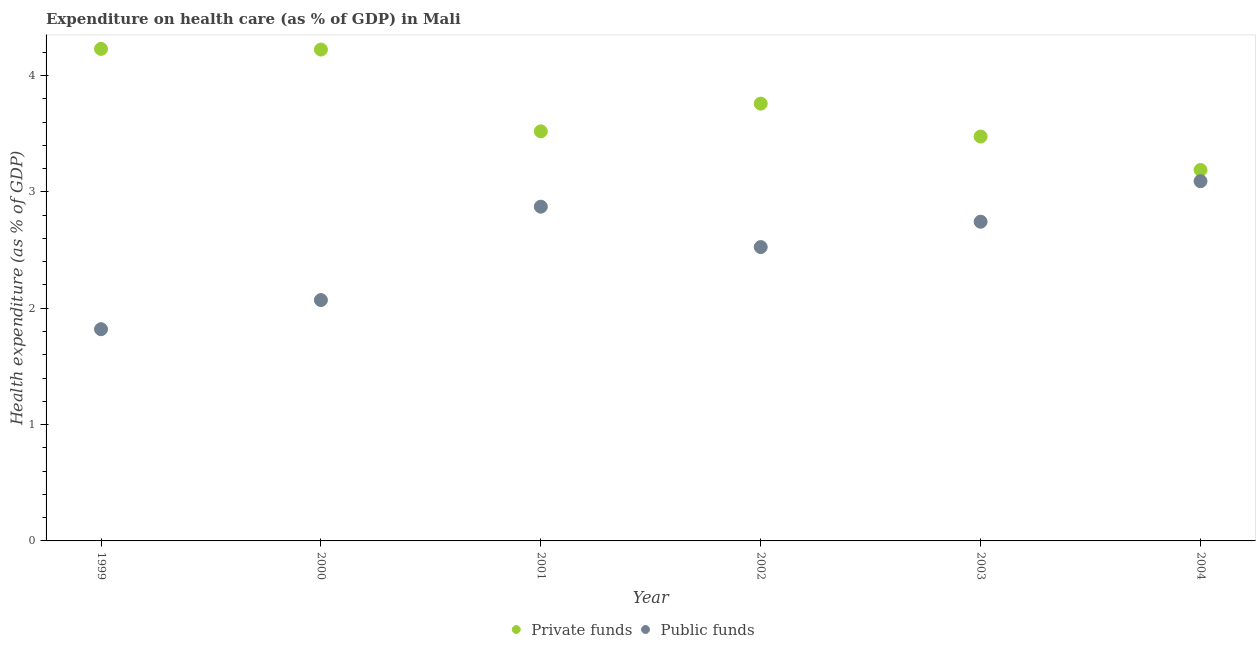How many different coloured dotlines are there?
Provide a short and direct response. 2. Is the number of dotlines equal to the number of legend labels?
Offer a very short reply. Yes. What is the amount of public funds spent in healthcare in 2000?
Provide a short and direct response. 2.07. Across all years, what is the maximum amount of private funds spent in healthcare?
Make the answer very short. 4.23. Across all years, what is the minimum amount of public funds spent in healthcare?
Offer a terse response. 1.82. In which year was the amount of private funds spent in healthcare maximum?
Ensure brevity in your answer.  1999. What is the total amount of public funds spent in healthcare in the graph?
Your response must be concise. 15.12. What is the difference between the amount of private funds spent in healthcare in 1999 and that in 2000?
Provide a short and direct response. 0.01. What is the difference between the amount of public funds spent in healthcare in 1999 and the amount of private funds spent in healthcare in 2002?
Your answer should be very brief. -1.94. What is the average amount of private funds spent in healthcare per year?
Make the answer very short. 3.73. In the year 2002, what is the difference between the amount of public funds spent in healthcare and amount of private funds spent in healthcare?
Provide a succinct answer. -1.23. In how many years, is the amount of public funds spent in healthcare greater than 4 %?
Your answer should be compact. 0. What is the ratio of the amount of private funds spent in healthcare in 1999 to that in 2004?
Offer a terse response. 1.33. Is the difference between the amount of public funds spent in healthcare in 2000 and 2001 greater than the difference between the amount of private funds spent in healthcare in 2000 and 2001?
Keep it short and to the point. No. What is the difference between the highest and the second highest amount of public funds spent in healthcare?
Offer a terse response. 0.22. What is the difference between the highest and the lowest amount of public funds spent in healthcare?
Give a very brief answer. 1.27. Does the amount of private funds spent in healthcare monotonically increase over the years?
Provide a succinct answer. No. Is the amount of public funds spent in healthcare strictly greater than the amount of private funds spent in healthcare over the years?
Offer a very short reply. No. How many dotlines are there?
Your answer should be compact. 2. How many years are there in the graph?
Offer a terse response. 6. Does the graph contain any zero values?
Provide a short and direct response. No. Where does the legend appear in the graph?
Keep it short and to the point. Bottom center. How are the legend labels stacked?
Ensure brevity in your answer.  Horizontal. What is the title of the graph?
Ensure brevity in your answer.  Expenditure on health care (as % of GDP) in Mali. Does "Fraud firms" appear as one of the legend labels in the graph?
Keep it short and to the point. No. What is the label or title of the X-axis?
Offer a very short reply. Year. What is the label or title of the Y-axis?
Ensure brevity in your answer.  Health expenditure (as % of GDP). What is the Health expenditure (as % of GDP) in Private funds in 1999?
Your answer should be very brief. 4.23. What is the Health expenditure (as % of GDP) of Public funds in 1999?
Offer a terse response. 1.82. What is the Health expenditure (as % of GDP) of Private funds in 2000?
Ensure brevity in your answer.  4.22. What is the Health expenditure (as % of GDP) of Public funds in 2000?
Keep it short and to the point. 2.07. What is the Health expenditure (as % of GDP) of Private funds in 2001?
Offer a very short reply. 3.52. What is the Health expenditure (as % of GDP) of Public funds in 2001?
Offer a very short reply. 2.87. What is the Health expenditure (as % of GDP) in Private funds in 2002?
Provide a short and direct response. 3.76. What is the Health expenditure (as % of GDP) of Public funds in 2002?
Offer a terse response. 2.53. What is the Health expenditure (as % of GDP) of Private funds in 2003?
Provide a succinct answer. 3.48. What is the Health expenditure (as % of GDP) of Public funds in 2003?
Provide a short and direct response. 2.74. What is the Health expenditure (as % of GDP) of Private funds in 2004?
Your answer should be compact. 3.19. What is the Health expenditure (as % of GDP) in Public funds in 2004?
Keep it short and to the point. 3.09. Across all years, what is the maximum Health expenditure (as % of GDP) of Private funds?
Give a very brief answer. 4.23. Across all years, what is the maximum Health expenditure (as % of GDP) of Public funds?
Ensure brevity in your answer.  3.09. Across all years, what is the minimum Health expenditure (as % of GDP) in Private funds?
Your answer should be compact. 3.19. Across all years, what is the minimum Health expenditure (as % of GDP) of Public funds?
Your answer should be very brief. 1.82. What is the total Health expenditure (as % of GDP) in Private funds in the graph?
Ensure brevity in your answer.  22.39. What is the total Health expenditure (as % of GDP) in Public funds in the graph?
Keep it short and to the point. 15.12. What is the difference between the Health expenditure (as % of GDP) in Private funds in 1999 and that in 2000?
Provide a short and direct response. 0.01. What is the difference between the Health expenditure (as % of GDP) in Public funds in 1999 and that in 2000?
Keep it short and to the point. -0.25. What is the difference between the Health expenditure (as % of GDP) of Private funds in 1999 and that in 2001?
Ensure brevity in your answer.  0.71. What is the difference between the Health expenditure (as % of GDP) in Public funds in 1999 and that in 2001?
Your response must be concise. -1.05. What is the difference between the Health expenditure (as % of GDP) in Private funds in 1999 and that in 2002?
Keep it short and to the point. 0.47. What is the difference between the Health expenditure (as % of GDP) in Public funds in 1999 and that in 2002?
Provide a succinct answer. -0.71. What is the difference between the Health expenditure (as % of GDP) in Private funds in 1999 and that in 2003?
Offer a terse response. 0.75. What is the difference between the Health expenditure (as % of GDP) of Public funds in 1999 and that in 2003?
Give a very brief answer. -0.92. What is the difference between the Health expenditure (as % of GDP) of Private funds in 1999 and that in 2004?
Your answer should be compact. 1.04. What is the difference between the Health expenditure (as % of GDP) of Public funds in 1999 and that in 2004?
Offer a very short reply. -1.27. What is the difference between the Health expenditure (as % of GDP) of Private funds in 2000 and that in 2001?
Keep it short and to the point. 0.7. What is the difference between the Health expenditure (as % of GDP) of Public funds in 2000 and that in 2001?
Your answer should be very brief. -0.8. What is the difference between the Health expenditure (as % of GDP) of Private funds in 2000 and that in 2002?
Provide a succinct answer. 0.46. What is the difference between the Health expenditure (as % of GDP) in Public funds in 2000 and that in 2002?
Make the answer very short. -0.46. What is the difference between the Health expenditure (as % of GDP) of Private funds in 2000 and that in 2003?
Give a very brief answer. 0.75. What is the difference between the Health expenditure (as % of GDP) in Public funds in 2000 and that in 2003?
Your answer should be very brief. -0.67. What is the difference between the Health expenditure (as % of GDP) of Private funds in 2000 and that in 2004?
Your answer should be compact. 1.04. What is the difference between the Health expenditure (as % of GDP) of Public funds in 2000 and that in 2004?
Your answer should be compact. -1.02. What is the difference between the Health expenditure (as % of GDP) in Private funds in 2001 and that in 2002?
Offer a terse response. -0.24. What is the difference between the Health expenditure (as % of GDP) of Public funds in 2001 and that in 2002?
Provide a succinct answer. 0.35. What is the difference between the Health expenditure (as % of GDP) in Private funds in 2001 and that in 2003?
Ensure brevity in your answer.  0.05. What is the difference between the Health expenditure (as % of GDP) in Public funds in 2001 and that in 2003?
Your answer should be compact. 0.13. What is the difference between the Health expenditure (as % of GDP) of Private funds in 2001 and that in 2004?
Offer a very short reply. 0.33. What is the difference between the Health expenditure (as % of GDP) in Public funds in 2001 and that in 2004?
Offer a terse response. -0.22. What is the difference between the Health expenditure (as % of GDP) of Private funds in 2002 and that in 2003?
Offer a terse response. 0.28. What is the difference between the Health expenditure (as % of GDP) of Public funds in 2002 and that in 2003?
Provide a succinct answer. -0.22. What is the difference between the Health expenditure (as % of GDP) in Private funds in 2002 and that in 2004?
Offer a very short reply. 0.57. What is the difference between the Health expenditure (as % of GDP) in Public funds in 2002 and that in 2004?
Ensure brevity in your answer.  -0.57. What is the difference between the Health expenditure (as % of GDP) of Private funds in 2003 and that in 2004?
Ensure brevity in your answer.  0.29. What is the difference between the Health expenditure (as % of GDP) of Public funds in 2003 and that in 2004?
Your answer should be compact. -0.35. What is the difference between the Health expenditure (as % of GDP) of Private funds in 1999 and the Health expenditure (as % of GDP) of Public funds in 2000?
Ensure brevity in your answer.  2.16. What is the difference between the Health expenditure (as % of GDP) of Private funds in 1999 and the Health expenditure (as % of GDP) of Public funds in 2001?
Your answer should be compact. 1.36. What is the difference between the Health expenditure (as % of GDP) in Private funds in 1999 and the Health expenditure (as % of GDP) in Public funds in 2002?
Offer a very short reply. 1.7. What is the difference between the Health expenditure (as % of GDP) in Private funds in 1999 and the Health expenditure (as % of GDP) in Public funds in 2003?
Keep it short and to the point. 1.49. What is the difference between the Health expenditure (as % of GDP) in Private funds in 1999 and the Health expenditure (as % of GDP) in Public funds in 2004?
Offer a very short reply. 1.14. What is the difference between the Health expenditure (as % of GDP) of Private funds in 2000 and the Health expenditure (as % of GDP) of Public funds in 2001?
Your answer should be very brief. 1.35. What is the difference between the Health expenditure (as % of GDP) of Private funds in 2000 and the Health expenditure (as % of GDP) of Public funds in 2002?
Give a very brief answer. 1.7. What is the difference between the Health expenditure (as % of GDP) of Private funds in 2000 and the Health expenditure (as % of GDP) of Public funds in 2003?
Provide a succinct answer. 1.48. What is the difference between the Health expenditure (as % of GDP) in Private funds in 2000 and the Health expenditure (as % of GDP) in Public funds in 2004?
Give a very brief answer. 1.13. What is the difference between the Health expenditure (as % of GDP) of Private funds in 2001 and the Health expenditure (as % of GDP) of Public funds in 2002?
Give a very brief answer. 0.99. What is the difference between the Health expenditure (as % of GDP) in Private funds in 2001 and the Health expenditure (as % of GDP) in Public funds in 2003?
Ensure brevity in your answer.  0.78. What is the difference between the Health expenditure (as % of GDP) in Private funds in 2001 and the Health expenditure (as % of GDP) in Public funds in 2004?
Keep it short and to the point. 0.43. What is the difference between the Health expenditure (as % of GDP) in Private funds in 2002 and the Health expenditure (as % of GDP) in Public funds in 2004?
Provide a short and direct response. 0.67. What is the difference between the Health expenditure (as % of GDP) in Private funds in 2003 and the Health expenditure (as % of GDP) in Public funds in 2004?
Your answer should be very brief. 0.38. What is the average Health expenditure (as % of GDP) of Private funds per year?
Provide a succinct answer. 3.73. What is the average Health expenditure (as % of GDP) of Public funds per year?
Your answer should be compact. 2.52. In the year 1999, what is the difference between the Health expenditure (as % of GDP) of Private funds and Health expenditure (as % of GDP) of Public funds?
Give a very brief answer. 2.41. In the year 2000, what is the difference between the Health expenditure (as % of GDP) of Private funds and Health expenditure (as % of GDP) of Public funds?
Offer a terse response. 2.15. In the year 2001, what is the difference between the Health expenditure (as % of GDP) of Private funds and Health expenditure (as % of GDP) of Public funds?
Your response must be concise. 0.65. In the year 2002, what is the difference between the Health expenditure (as % of GDP) of Private funds and Health expenditure (as % of GDP) of Public funds?
Your answer should be compact. 1.23. In the year 2003, what is the difference between the Health expenditure (as % of GDP) of Private funds and Health expenditure (as % of GDP) of Public funds?
Keep it short and to the point. 0.73. In the year 2004, what is the difference between the Health expenditure (as % of GDP) of Private funds and Health expenditure (as % of GDP) of Public funds?
Your answer should be very brief. 0.1. What is the ratio of the Health expenditure (as % of GDP) in Private funds in 1999 to that in 2000?
Provide a short and direct response. 1. What is the ratio of the Health expenditure (as % of GDP) of Public funds in 1999 to that in 2000?
Make the answer very short. 0.88. What is the ratio of the Health expenditure (as % of GDP) in Private funds in 1999 to that in 2001?
Provide a short and direct response. 1.2. What is the ratio of the Health expenditure (as % of GDP) of Public funds in 1999 to that in 2001?
Offer a very short reply. 0.63. What is the ratio of the Health expenditure (as % of GDP) of Private funds in 1999 to that in 2002?
Provide a succinct answer. 1.13. What is the ratio of the Health expenditure (as % of GDP) of Public funds in 1999 to that in 2002?
Your answer should be compact. 0.72. What is the ratio of the Health expenditure (as % of GDP) of Private funds in 1999 to that in 2003?
Your response must be concise. 1.22. What is the ratio of the Health expenditure (as % of GDP) of Public funds in 1999 to that in 2003?
Keep it short and to the point. 0.66. What is the ratio of the Health expenditure (as % of GDP) of Private funds in 1999 to that in 2004?
Make the answer very short. 1.33. What is the ratio of the Health expenditure (as % of GDP) in Public funds in 1999 to that in 2004?
Offer a very short reply. 0.59. What is the ratio of the Health expenditure (as % of GDP) in Private funds in 2000 to that in 2001?
Offer a terse response. 1.2. What is the ratio of the Health expenditure (as % of GDP) in Public funds in 2000 to that in 2001?
Offer a terse response. 0.72. What is the ratio of the Health expenditure (as % of GDP) of Private funds in 2000 to that in 2002?
Your response must be concise. 1.12. What is the ratio of the Health expenditure (as % of GDP) of Public funds in 2000 to that in 2002?
Keep it short and to the point. 0.82. What is the ratio of the Health expenditure (as % of GDP) in Private funds in 2000 to that in 2003?
Offer a terse response. 1.22. What is the ratio of the Health expenditure (as % of GDP) of Public funds in 2000 to that in 2003?
Your response must be concise. 0.75. What is the ratio of the Health expenditure (as % of GDP) of Private funds in 2000 to that in 2004?
Offer a terse response. 1.32. What is the ratio of the Health expenditure (as % of GDP) of Public funds in 2000 to that in 2004?
Ensure brevity in your answer.  0.67. What is the ratio of the Health expenditure (as % of GDP) in Private funds in 2001 to that in 2002?
Offer a terse response. 0.94. What is the ratio of the Health expenditure (as % of GDP) of Public funds in 2001 to that in 2002?
Provide a succinct answer. 1.14. What is the ratio of the Health expenditure (as % of GDP) of Public funds in 2001 to that in 2003?
Your response must be concise. 1.05. What is the ratio of the Health expenditure (as % of GDP) of Private funds in 2001 to that in 2004?
Offer a terse response. 1.1. What is the ratio of the Health expenditure (as % of GDP) of Public funds in 2001 to that in 2004?
Ensure brevity in your answer.  0.93. What is the ratio of the Health expenditure (as % of GDP) in Private funds in 2002 to that in 2003?
Keep it short and to the point. 1.08. What is the ratio of the Health expenditure (as % of GDP) of Public funds in 2002 to that in 2003?
Make the answer very short. 0.92. What is the ratio of the Health expenditure (as % of GDP) of Private funds in 2002 to that in 2004?
Offer a very short reply. 1.18. What is the ratio of the Health expenditure (as % of GDP) of Public funds in 2002 to that in 2004?
Give a very brief answer. 0.82. What is the ratio of the Health expenditure (as % of GDP) of Private funds in 2003 to that in 2004?
Your answer should be very brief. 1.09. What is the ratio of the Health expenditure (as % of GDP) in Public funds in 2003 to that in 2004?
Ensure brevity in your answer.  0.89. What is the difference between the highest and the second highest Health expenditure (as % of GDP) of Private funds?
Provide a succinct answer. 0.01. What is the difference between the highest and the second highest Health expenditure (as % of GDP) of Public funds?
Keep it short and to the point. 0.22. What is the difference between the highest and the lowest Health expenditure (as % of GDP) in Private funds?
Offer a terse response. 1.04. What is the difference between the highest and the lowest Health expenditure (as % of GDP) in Public funds?
Your answer should be compact. 1.27. 